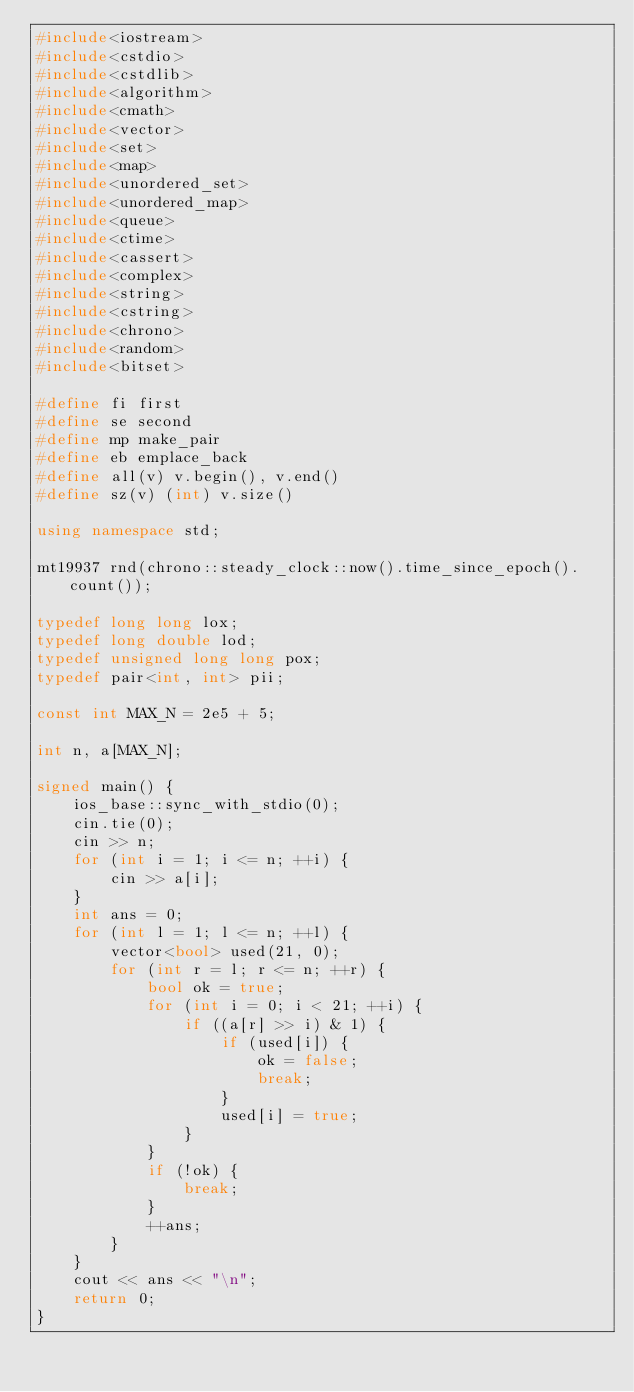Convert code to text. <code><loc_0><loc_0><loc_500><loc_500><_C++_>#include<iostream>
#include<cstdio>
#include<cstdlib>
#include<algorithm>
#include<cmath>
#include<vector>
#include<set>
#include<map>
#include<unordered_set>
#include<unordered_map>
#include<queue>
#include<ctime>
#include<cassert>
#include<complex>
#include<string>
#include<cstring>
#include<chrono>
#include<random>
#include<bitset>

#define fi first
#define se second
#define mp make_pair
#define eb emplace_back
#define all(v) v.begin(), v.end()
#define sz(v) (int) v.size()

using namespace std;

mt19937 rnd(chrono::steady_clock::now().time_since_epoch().count());

typedef long long lox;
typedef long double lod;
typedef unsigned long long pox;
typedef pair<int, int> pii;

const int MAX_N = 2e5 + 5;

int n, a[MAX_N];

signed main() {
	ios_base::sync_with_stdio(0);
	cin.tie(0);
	cin >> n;
	for (int i = 1; i <= n; ++i) {
		cin >> a[i];
	}
	int ans = 0;
	for (int l = 1; l <= n; ++l) {
		vector<bool> used(21, 0);
		for (int r = l; r <= n; ++r) {
			bool ok = true;
			for (int i = 0; i < 21; ++i) {
				if ((a[r] >> i) & 1) {
					if (used[i]) {
						ok = false;
						break;
					}
					used[i] = true;
				}
			}
			if (!ok) {
				break;
			}
			++ans;
		}
	}
	cout << ans << "\n";
	return 0;
}</code> 